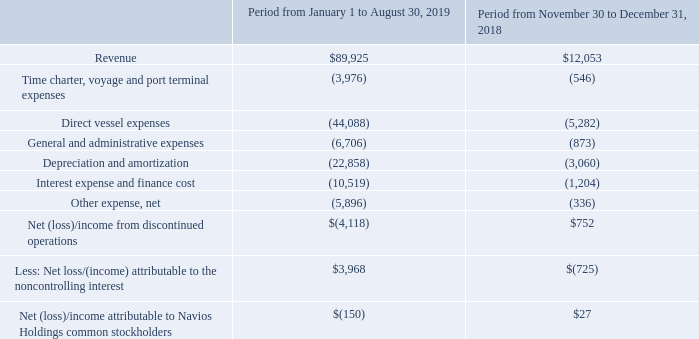NAVIOS MARITIME HOLDINGS INC. NOTES TO THE CONSOLIDATED FINANCIAL STATEMENTS (Expressed in thousands of U.S. dollars — except share data)
Amounts recorded in respect of discontinued operations in the years ended December 31, 2019 and 2018, respectively are as follows:
Navios Containers accounted for the control obtained in November 2018 as a business combination which resulted in the application of the “acquisition method”, as defined under ASC 805 Business Combinations, as well as the recalculation of Navios Holdings’ equity interest in Navios Containers to its fair value at the date of obtaining control and the recognition of a gain in the consolidated statements of comprehensive (loss)/income. The excess of the fair value of Navios Containers’ identifiable net assets of $229,865 over the total fair value of Navios Containers’ total shares outstanding as of November 30, 2018 of $171,743, resulted in a bargain gain upon obtaining control in the amount of $58,122. The fair value of the 34,603,100 total Navios Container’s shares outstanding as of November 30, 2018 was determined by using the closing share price of $4.96, as of that date.
As of November 30, 2018, Navios Holdings’ interest in Navios Containers with a carrying value of $6,078 was remeasured to fair value of $6,269, resulting in a gain on obtaining control in the amount of $191 and is presented within “Bargain gain upon obtaining control” in the consolidated statements of comprehensive (loss)/income.
The results of operations of Navios Containers are included in Navios Holdings’ consolidated statements of comprehensive (loss)/income following the completion of the conversion of Navios Maritime Containers Inc. into a limited partnership on November 30, 2018.
Which years does the table provide information for discontinued operations? 2019, 2018. What was the revenue in 2018?
Answer scale should be: thousand. 12,053. What were the General and administrative expenses in 2018?
Answer scale should be: thousand. (873). How many years did revenue exceed $50,000 thousand? 2019
Answer: 1. What was the change in direct vessel expenses between 2018 and 2019?
Answer scale should be: thousand. -44,088-(-5,282)
Answer: -38806. What was the percentage change in Interest expense and finance cost between 2018 and 2019?
Answer scale should be: percent. (-10,519-(-1,204))/-1,204
Answer: 773.67. 